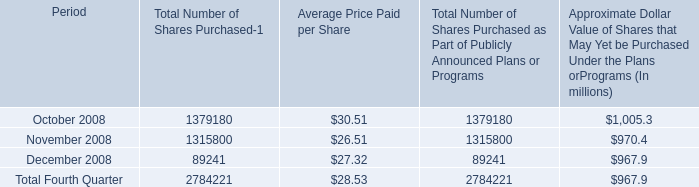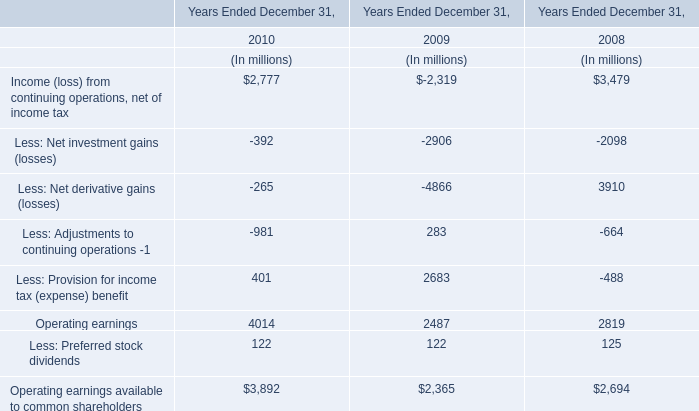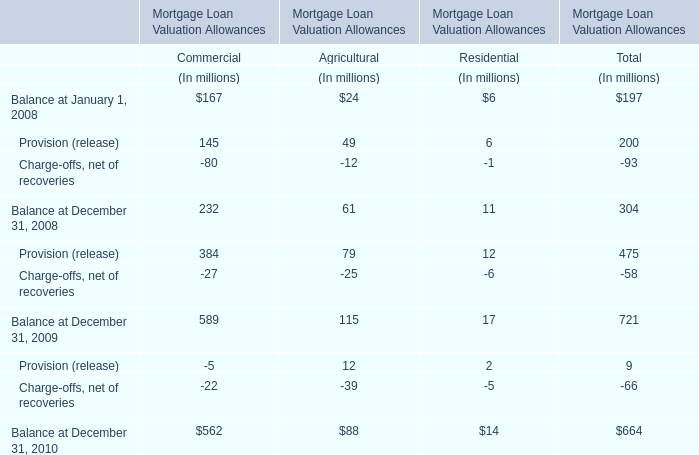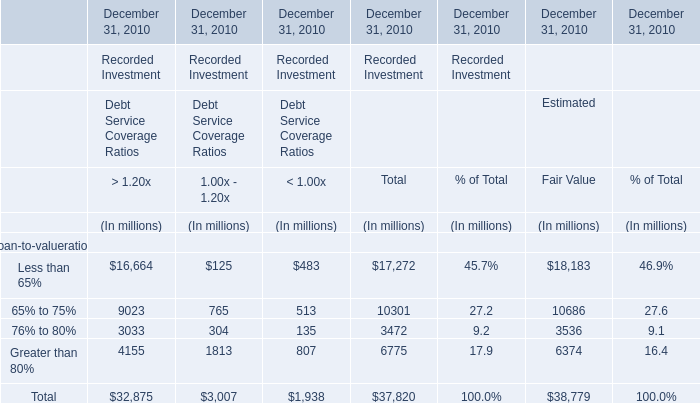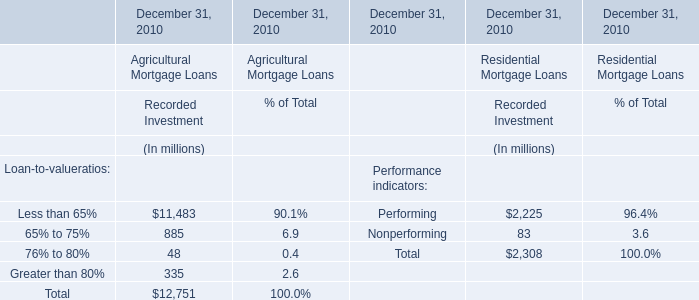what is the percentage change in the average price for repurchased shares from october to december 2008? 
Computations: ((27.32 - 30.51) / 30.51)
Answer: -0.10456. 